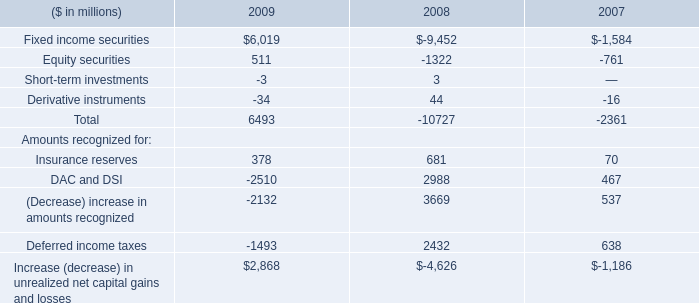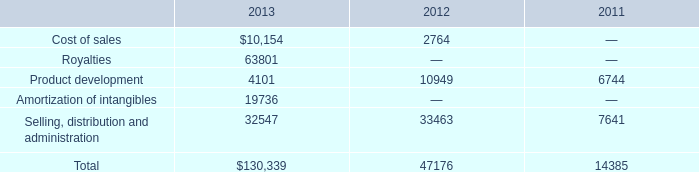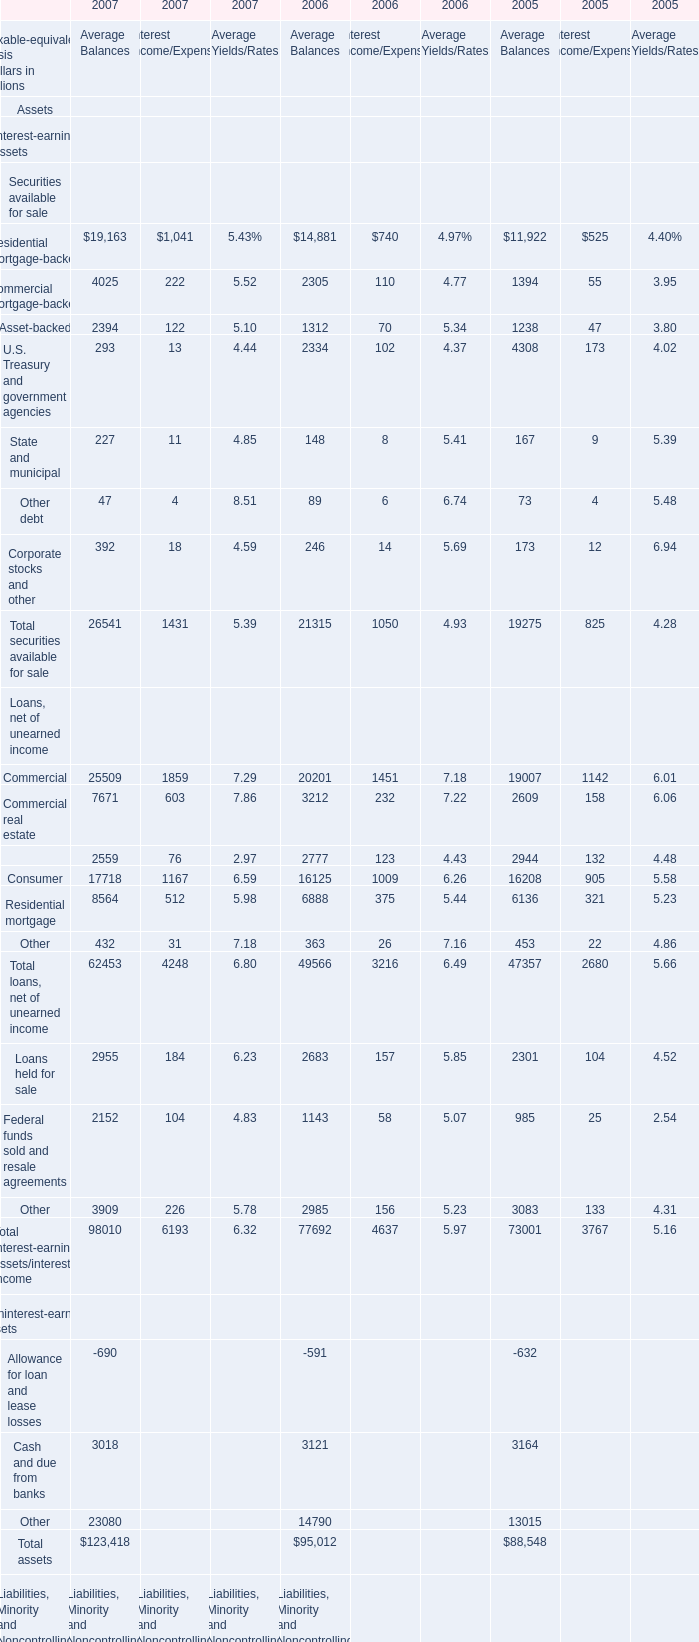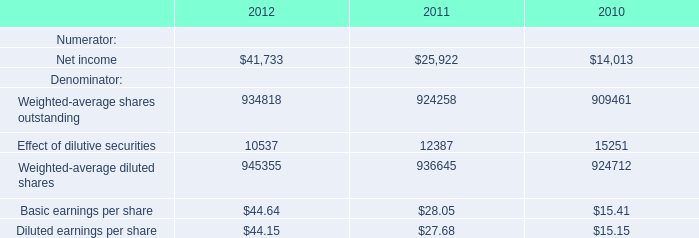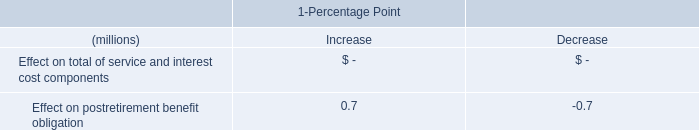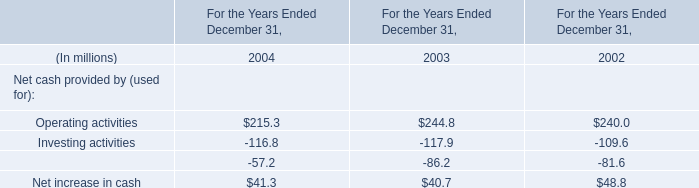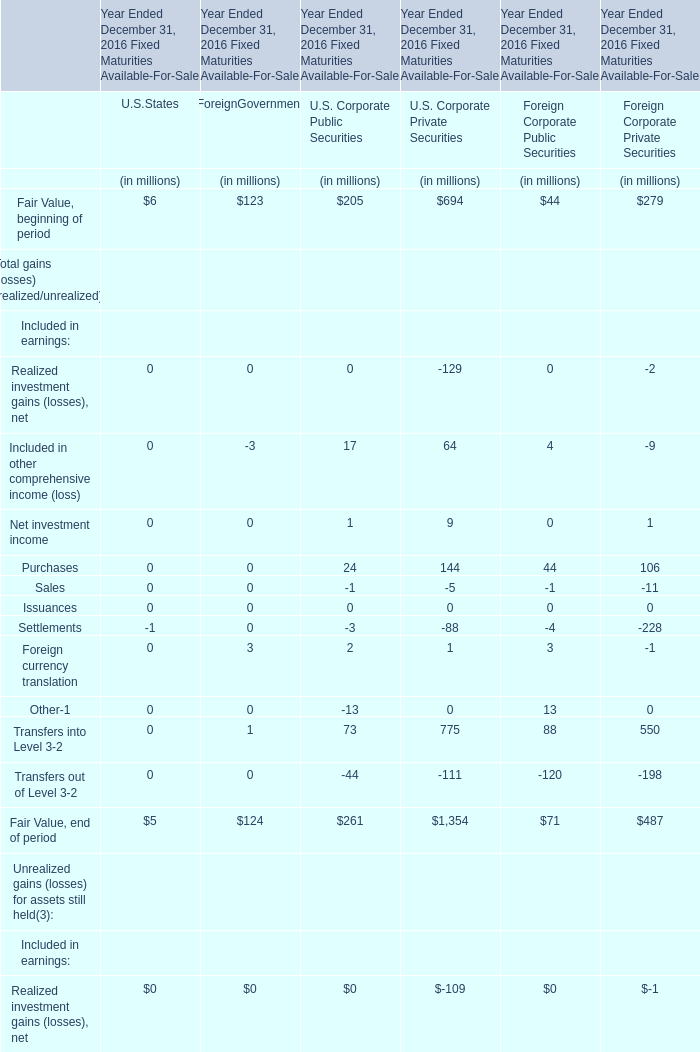As As the chart 2 shows,what is the increasing rate of the Interest Income for Total securities available for sale between 2006 and 2007? 
Computations: ((1431 - 1050) / 1050)
Answer: 0.36286. 